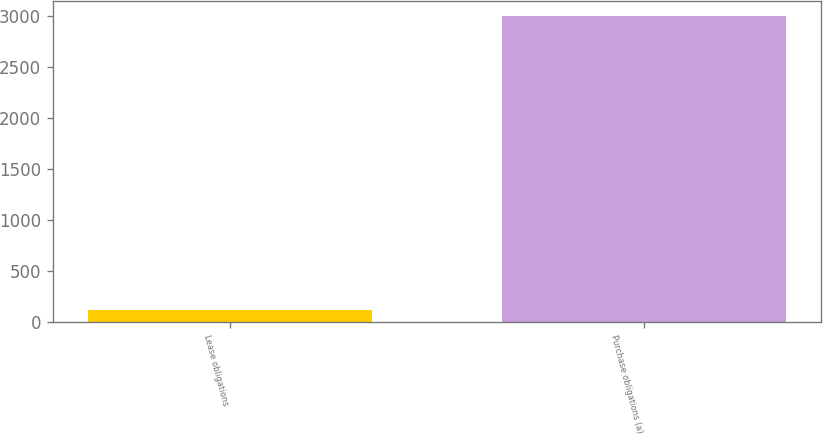<chart> <loc_0><loc_0><loc_500><loc_500><bar_chart><fcel>Lease obligations<fcel>Purchase obligations (a)<nl><fcel>118<fcel>3001<nl></chart> 